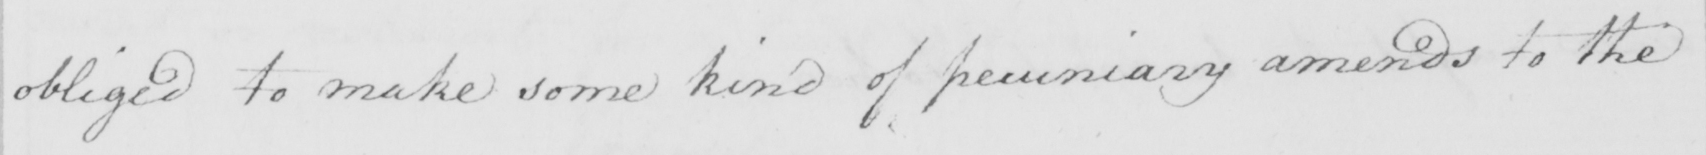What is written in this line of handwriting? obliged to make some kind of pecuniary amends to the 